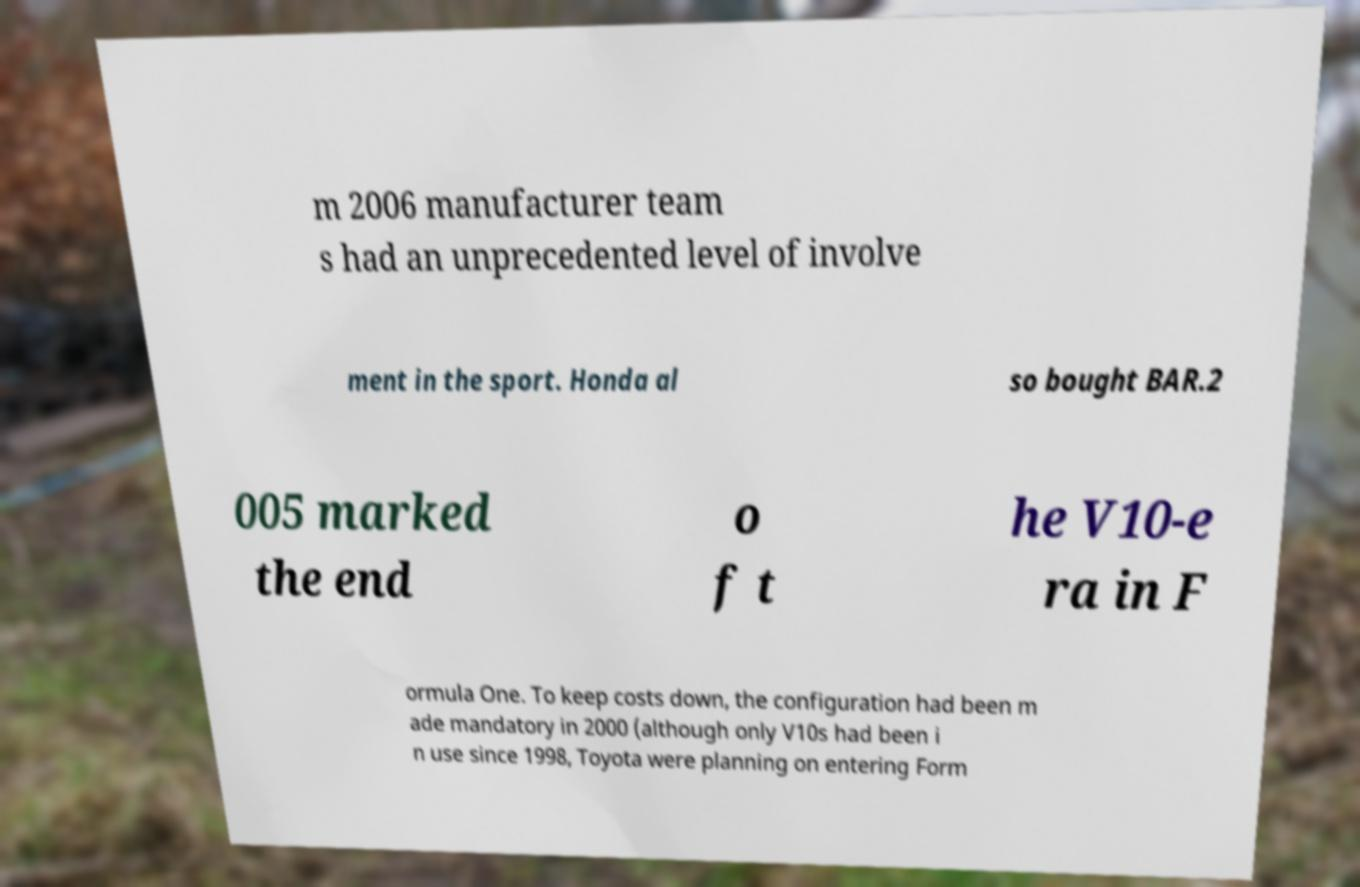There's text embedded in this image that I need extracted. Can you transcribe it verbatim? m 2006 manufacturer team s had an unprecedented level of involve ment in the sport. Honda al so bought BAR.2 005 marked the end o f t he V10-e ra in F ormula One. To keep costs down, the configuration had been m ade mandatory in 2000 (although only V10s had been i n use since 1998, Toyota were planning on entering Form 